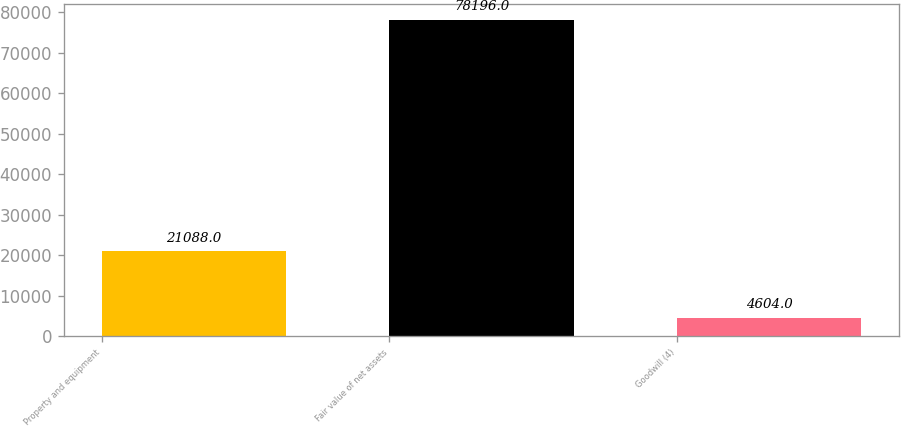<chart> <loc_0><loc_0><loc_500><loc_500><bar_chart><fcel>Property and equipment<fcel>Fair value of net assets<fcel>Goodwill (4)<nl><fcel>21088<fcel>78196<fcel>4604<nl></chart> 